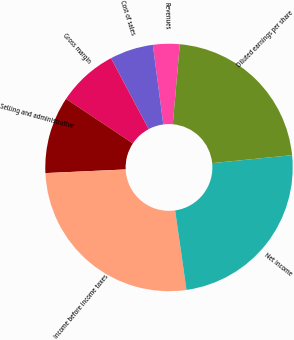Convert chart to OTSL. <chart><loc_0><loc_0><loc_500><loc_500><pie_chart><fcel>Revenues<fcel>Cost of sales<fcel>Gross margin<fcel>Selling and administrative<fcel>Income before income taxes<fcel>Net income<fcel>Diluted earnings per share<nl><fcel>3.48%<fcel>5.68%<fcel>7.88%<fcel>10.08%<fcel>26.54%<fcel>24.33%<fcel>22.02%<nl></chart> 